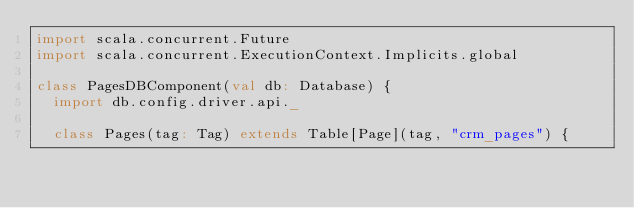<code> <loc_0><loc_0><loc_500><loc_500><_Scala_>import scala.concurrent.Future
import scala.concurrent.ExecutionContext.Implicits.global

class PagesDBComponent(val db: Database) {
  import db.config.driver.api._
  
  class Pages(tag: Tag) extends Table[Page](tag, "crm_pages") {</code> 